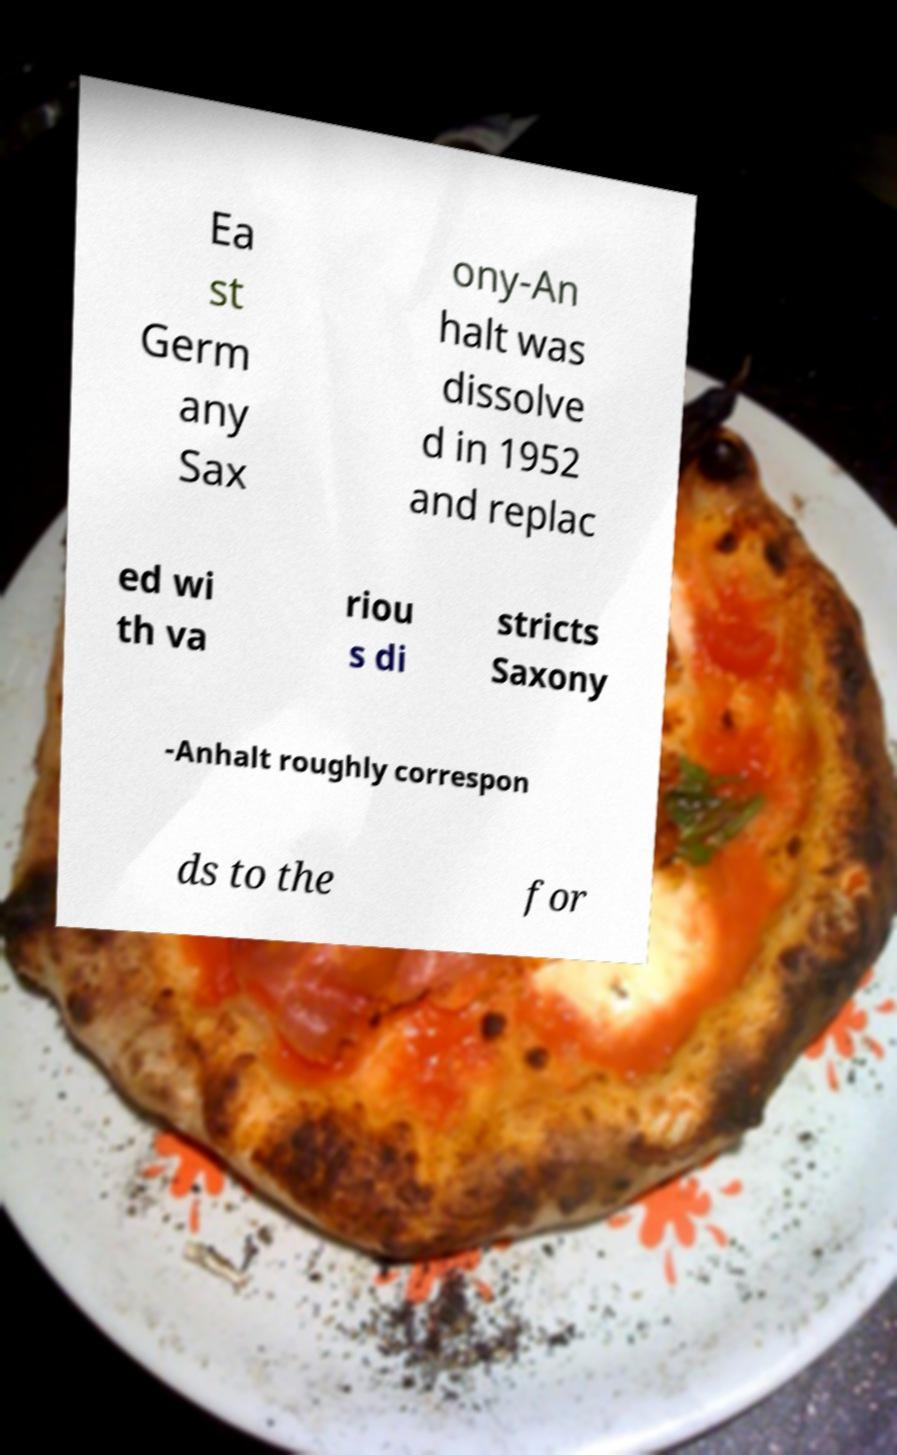For documentation purposes, I need the text within this image transcribed. Could you provide that? Ea st Germ any Sax ony-An halt was dissolve d in 1952 and replac ed wi th va riou s di stricts Saxony -Anhalt roughly correspon ds to the for 